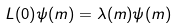<formula> <loc_0><loc_0><loc_500><loc_500>L ( 0 ) \psi ( m ) = \lambda ( m ) \psi ( m )</formula> 